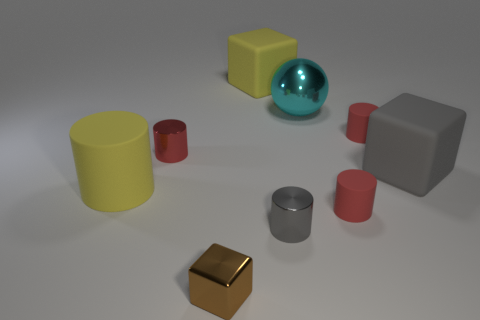What is the color of the small metallic object that is the same shape as the large gray matte thing?
Provide a short and direct response. Brown. What number of matte things are gray cylinders or small brown things?
Ensure brevity in your answer.  0. There is a red cylinder behind the red thing left of the shiny cube; are there any metal blocks that are behind it?
Offer a terse response. No. The large rubber cylinder has what color?
Offer a very short reply. Yellow. There is a small shiny object behind the small gray object; is it the same shape as the large metallic thing?
Offer a terse response. No. How many objects are either brown metallic things or small brown cubes in front of the shiny sphere?
Your answer should be compact. 1. Are the big yellow thing left of the tiny brown cube and the big cyan object made of the same material?
Make the answer very short. No. There is a small cylinder on the left side of the rubber block behind the cyan sphere; what is it made of?
Provide a succinct answer. Metal. Are there more metal things that are behind the metallic block than metallic cylinders left of the large yellow block?
Your answer should be compact. Yes. The yellow matte block has what size?
Provide a succinct answer. Large. 